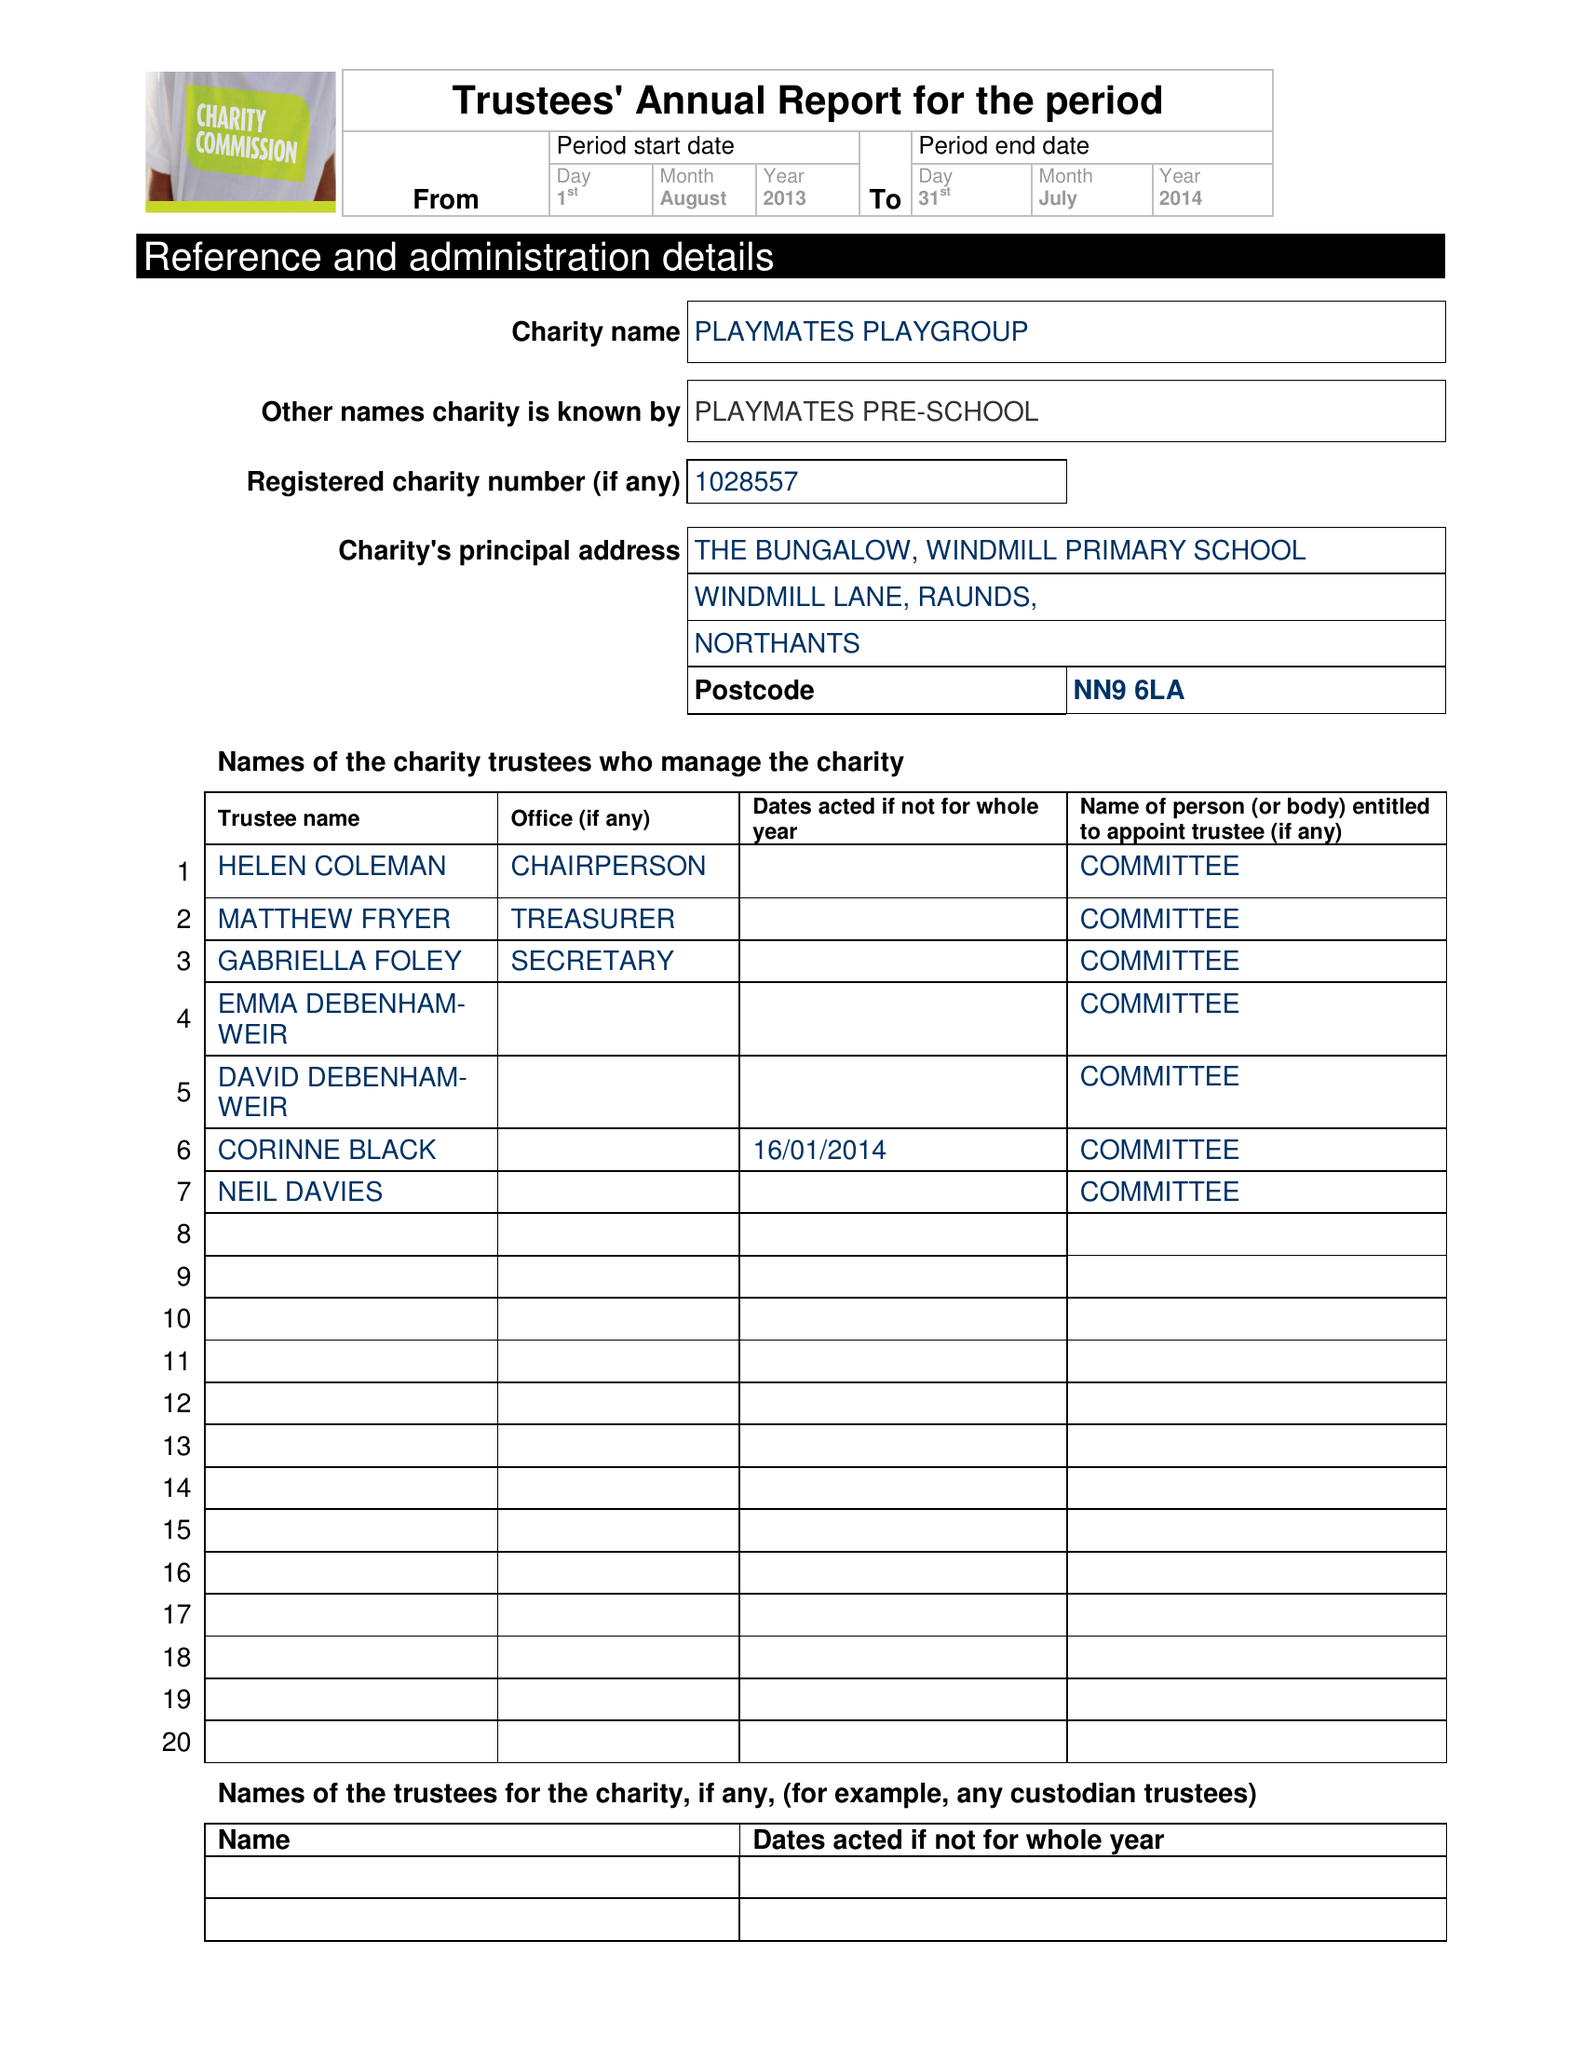What is the value for the income_annually_in_british_pounds?
Answer the question using a single word or phrase. 67185.00 